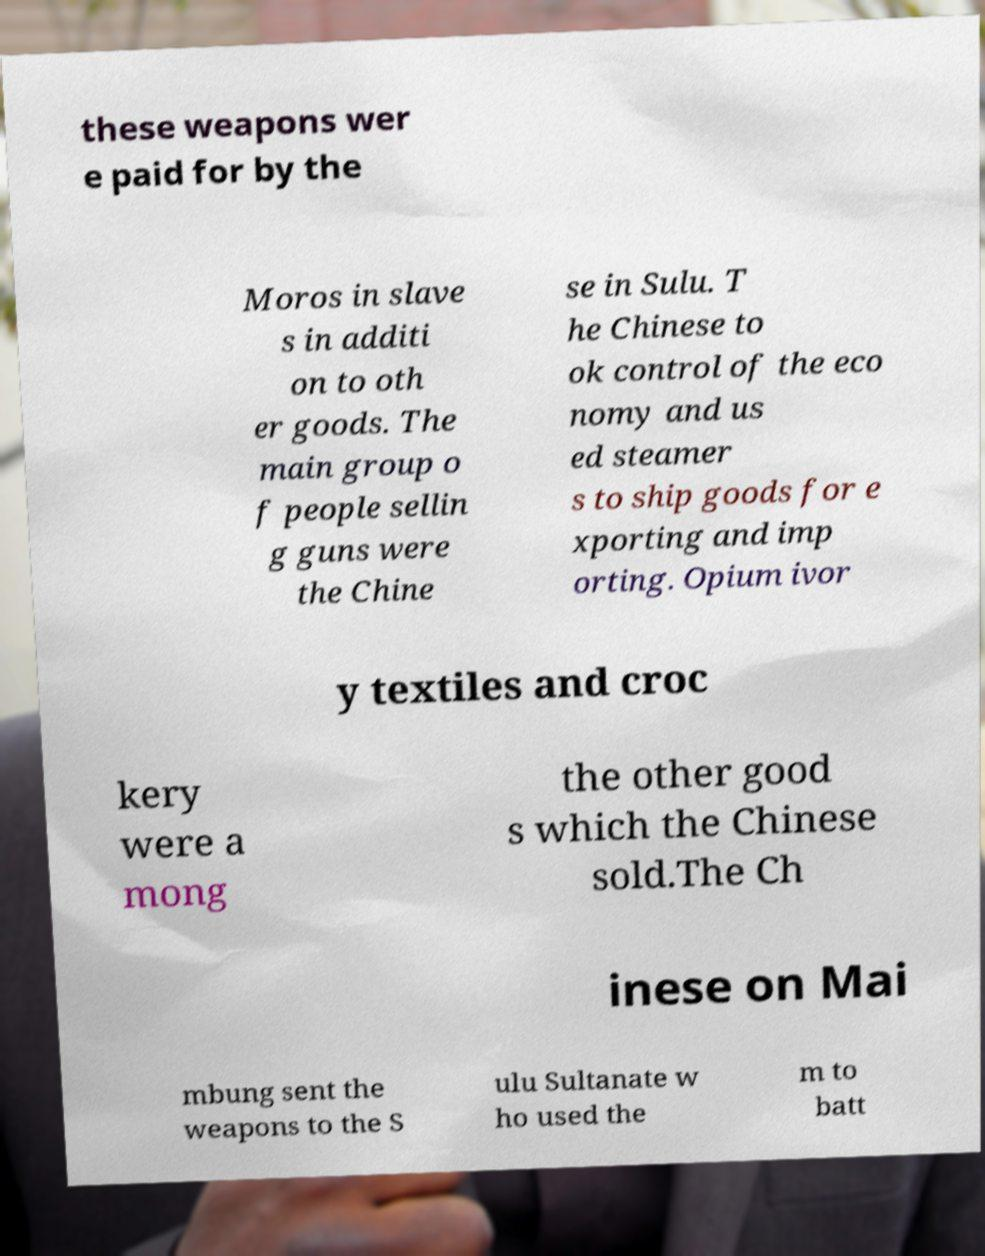What messages or text are displayed in this image? I need them in a readable, typed format. these weapons wer e paid for by the Moros in slave s in additi on to oth er goods. The main group o f people sellin g guns were the Chine se in Sulu. T he Chinese to ok control of the eco nomy and us ed steamer s to ship goods for e xporting and imp orting. Opium ivor y textiles and croc kery were a mong the other good s which the Chinese sold.The Ch inese on Mai mbung sent the weapons to the S ulu Sultanate w ho used the m to batt 